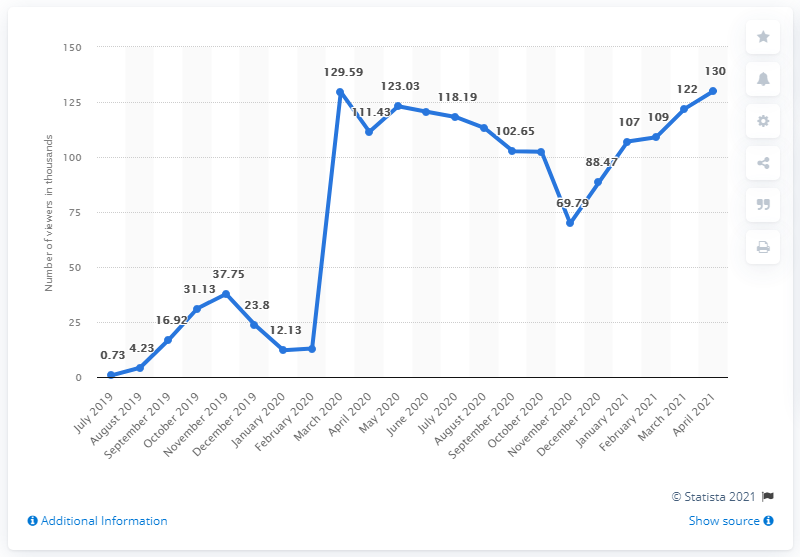List a handful of essential elements in this visual. The line graph shows the movement of points from July 2019 to April 2021, and the total number of points that moved during this period is 22. Call of Duty: Warzone was released in March 2020. The graph reached a high point in March 2020. 